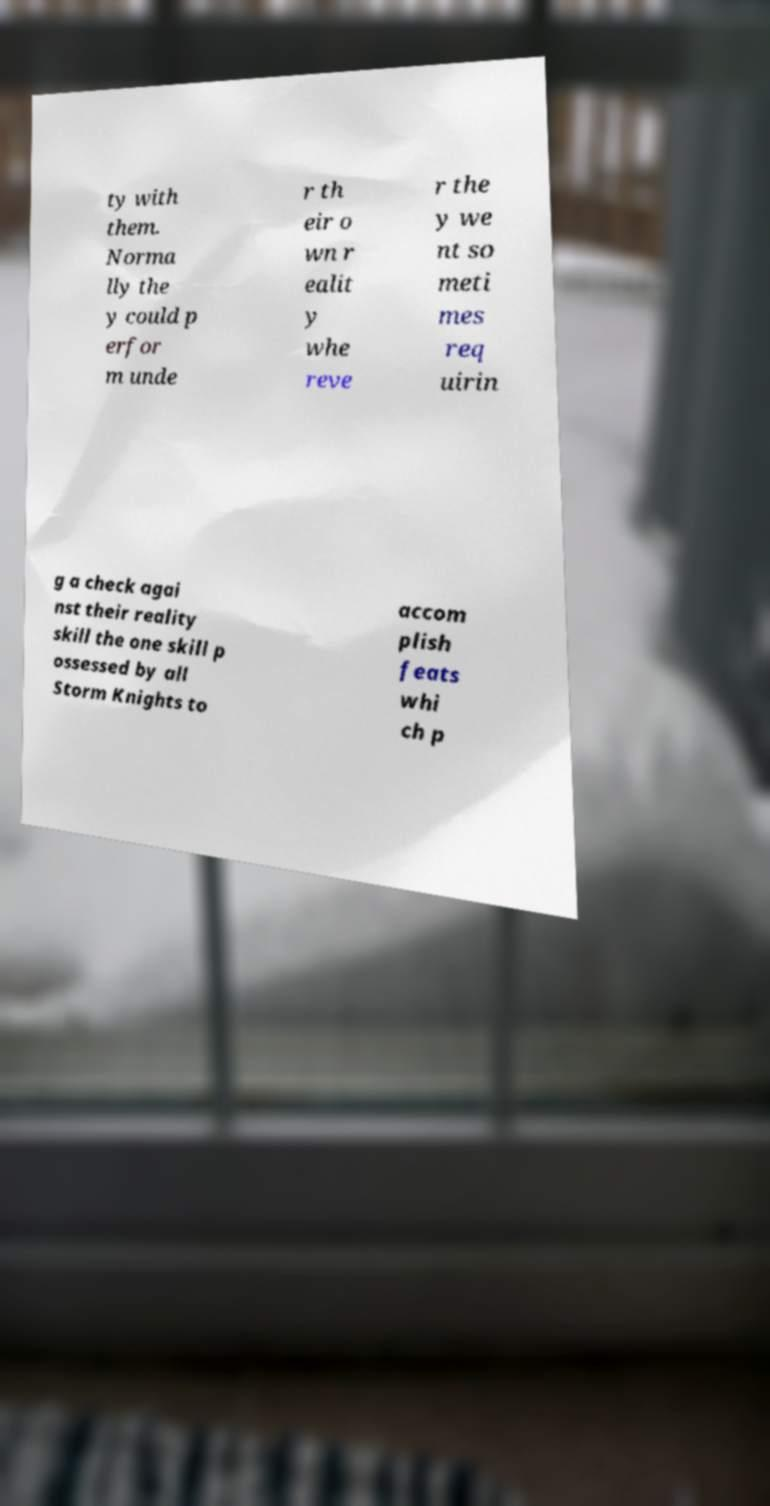Please read and relay the text visible in this image. What does it say? ty with them. Norma lly the y could p erfor m unde r th eir o wn r ealit y whe reve r the y we nt so meti mes req uirin g a check agai nst their reality skill the one skill p ossessed by all Storm Knights to accom plish feats whi ch p 